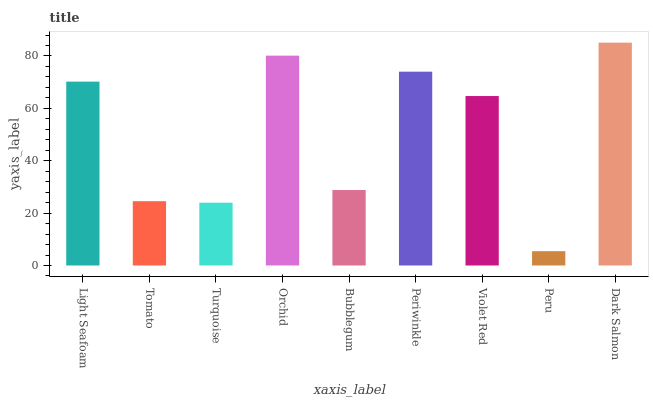Is Peru the minimum?
Answer yes or no. Yes. Is Dark Salmon the maximum?
Answer yes or no. Yes. Is Tomato the minimum?
Answer yes or no. No. Is Tomato the maximum?
Answer yes or no. No. Is Light Seafoam greater than Tomato?
Answer yes or no. Yes. Is Tomato less than Light Seafoam?
Answer yes or no. Yes. Is Tomato greater than Light Seafoam?
Answer yes or no. No. Is Light Seafoam less than Tomato?
Answer yes or no. No. Is Violet Red the high median?
Answer yes or no. Yes. Is Violet Red the low median?
Answer yes or no. Yes. Is Light Seafoam the high median?
Answer yes or no. No. Is Orchid the low median?
Answer yes or no. No. 